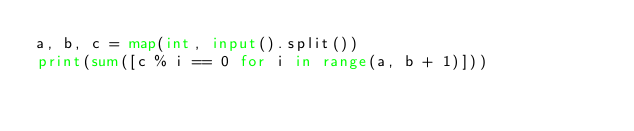<code> <loc_0><loc_0><loc_500><loc_500><_Python_>a, b, c = map(int, input().split())
print(sum([c % i == 0 for i in range(a, b + 1)]))
</code> 